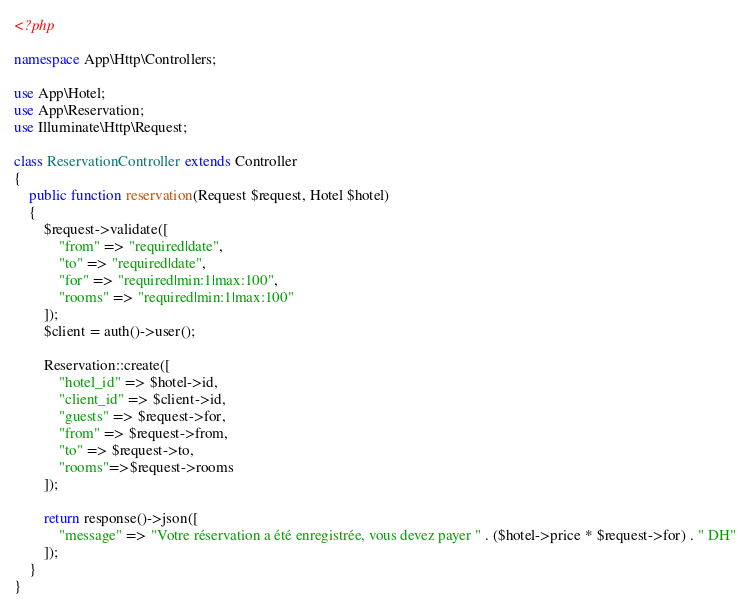Convert code to text. <code><loc_0><loc_0><loc_500><loc_500><_PHP_><?php

namespace App\Http\Controllers;

use App\Hotel;
use App\Reservation;
use Illuminate\Http\Request;

class ReservationController extends Controller
{
    public function reservation(Request $request, Hotel $hotel)
    {
        $request->validate([
            "from" => "required|date",
            "to" => "required|date",
            "for" => "required|min:1|max:100",
            "rooms" => "required|min:1|max:100"
        ]);
        $client = auth()->user();

        Reservation::create([
            "hotel_id" => $hotel->id,
            "client_id" => $client->id,
            "guests" => $request->for,
            "from" => $request->from,
            "to" => $request->to,
            "rooms"=>$request->rooms
        ]);

        return response()->json([
            "message" => "Votre réservation a été enregistrée, vous devez payer " . ($hotel->price * $request->for) . " DH"
        ]);
    }
}
</code> 